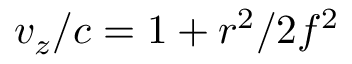Convert formula to latex. <formula><loc_0><loc_0><loc_500><loc_500>v _ { z } / c = 1 + r ^ { 2 } / 2 f ^ { 2 }</formula> 